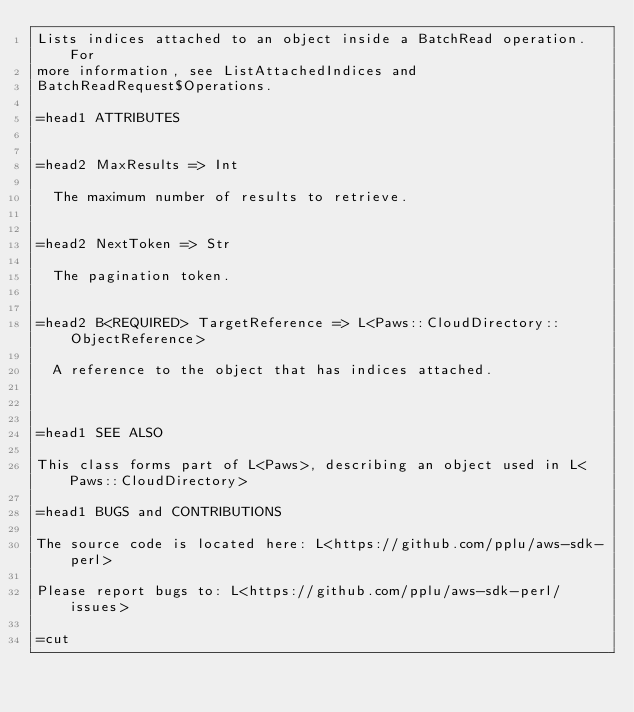Convert code to text. <code><loc_0><loc_0><loc_500><loc_500><_Perl_>Lists indices attached to an object inside a BatchRead operation. For
more information, see ListAttachedIndices and
BatchReadRequest$Operations.

=head1 ATTRIBUTES


=head2 MaxResults => Int

  The maximum number of results to retrieve.


=head2 NextToken => Str

  The pagination token.


=head2 B<REQUIRED> TargetReference => L<Paws::CloudDirectory::ObjectReference>

  A reference to the object that has indices attached.



=head1 SEE ALSO

This class forms part of L<Paws>, describing an object used in L<Paws::CloudDirectory>

=head1 BUGS and CONTRIBUTIONS

The source code is located here: L<https://github.com/pplu/aws-sdk-perl>

Please report bugs to: L<https://github.com/pplu/aws-sdk-perl/issues>

=cut

</code> 